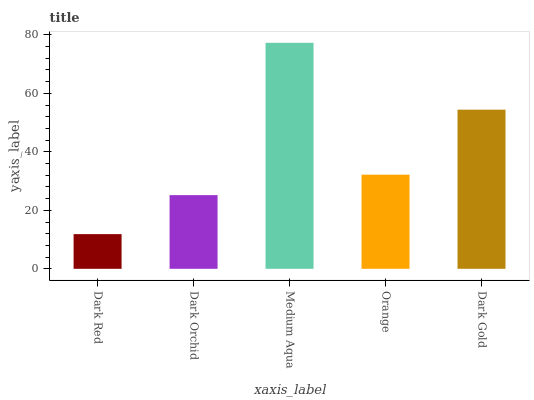Is Dark Orchid the minimum?
Answer yes or no. No. Is Dark Orchid the maximum?
Answer yes or no. No. Is Dark Orchid greater than Dark Red?
Answer yes or no. Yes. Is Dark Red less than Dark Orchid?
Answer yes or no. Yes. Is Dark Red greater than Dark Orchid?
Answer yes or no. No. Is Dark Orchid less than Dark Red?
Answer yes or no. No. Is Orange the high median?
Answer yes or no. Yes. Is Orange the low median?
Answer yes or no. Yes. Is Dark Gold the high median?
Answer yes or no. No. Is Medium Aqua the low median?
Answer yes or no. No. 